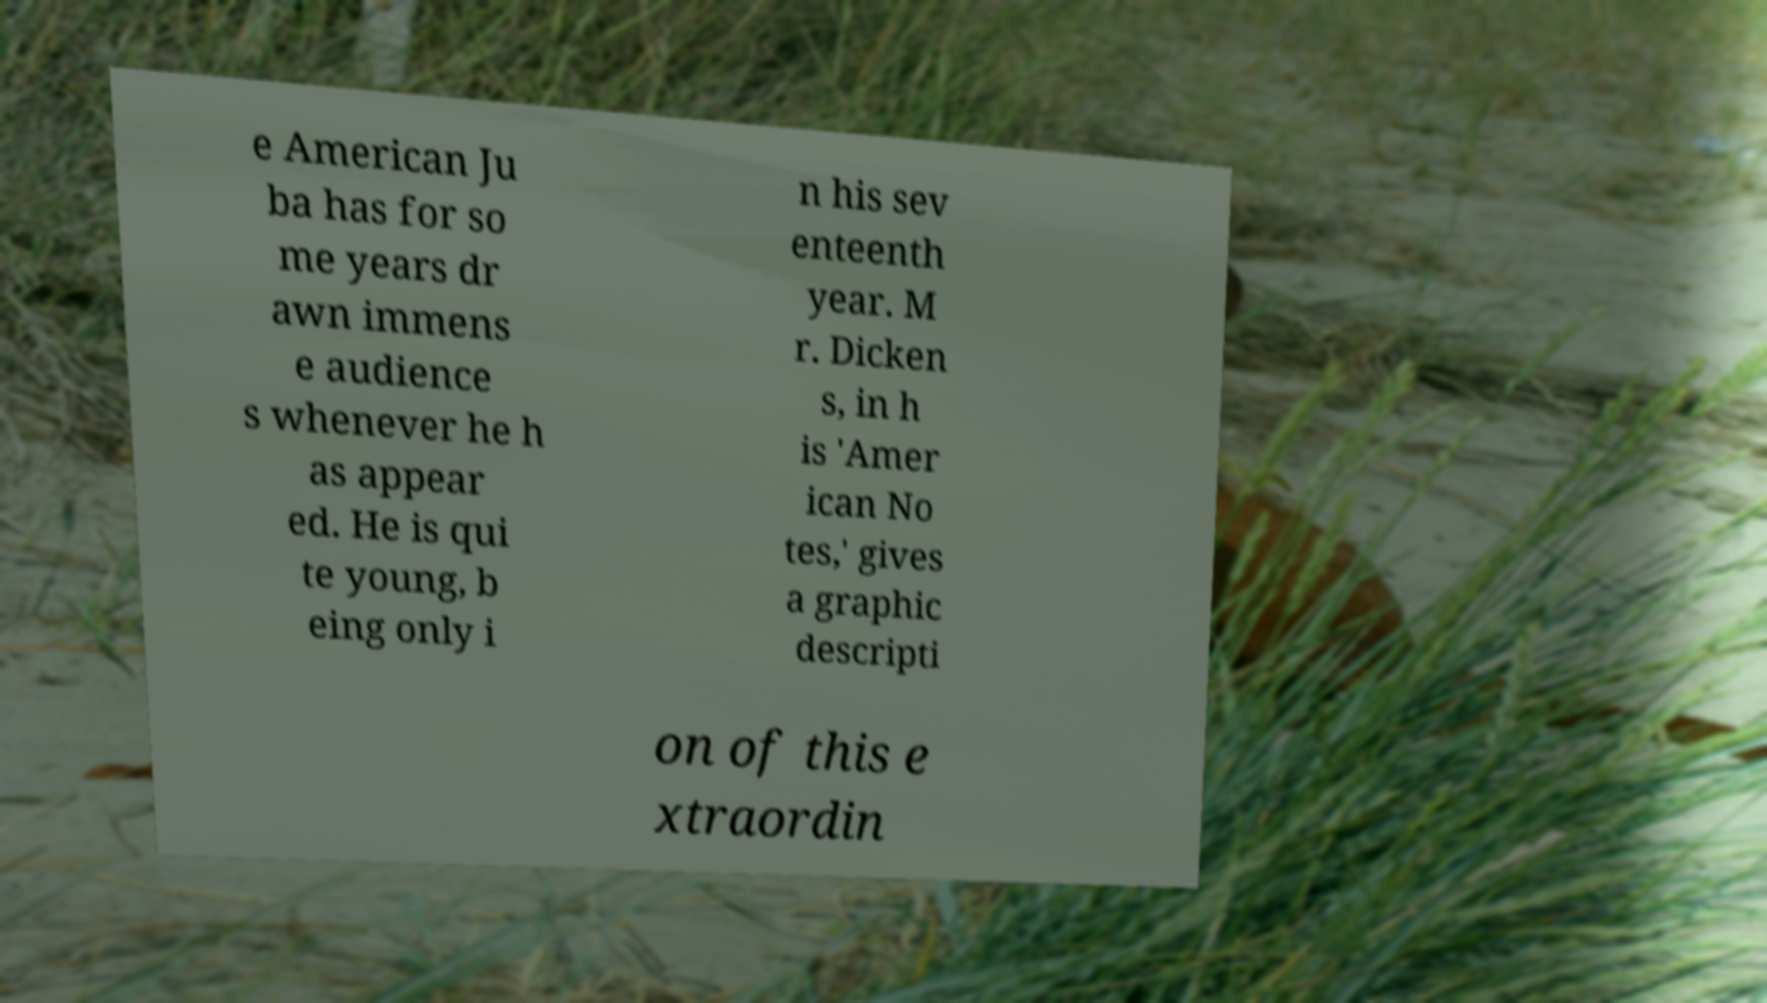Could you extract and type out the text from this image? e American Ju ba has for so me years dr awn immens e audience s whenever he h as appear ed. He is qui te young, b eing only i n his sev enteenth year. M r. Dicken s, in h is 'Amer ican No tes,' gives a graphic descripti on of this e xtraordin 